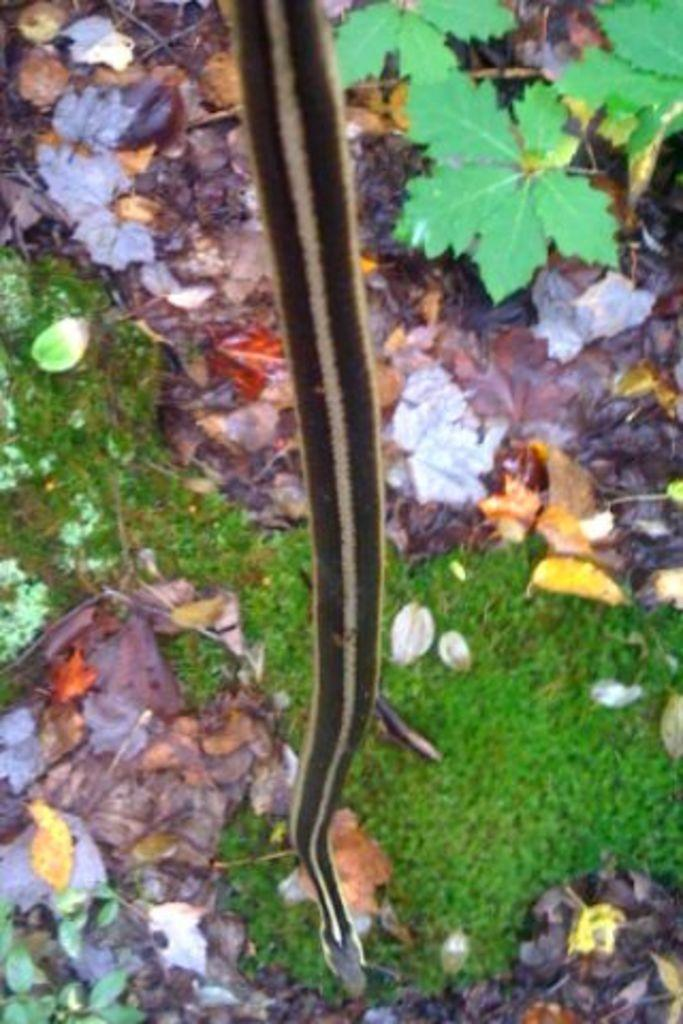What type of animal can be seen in the picture? There is a snake in the picture. What type of vegetation is present in the picture? There is grass and plants in the picture. What can be found on the floor in the picture? Dry leaves are present on the floor in the picture. How many rabbits can be seen hopping around in the picture? There are no rabbits present in the image; it features a snake and vegetation. What type of wish can be granted by the snake in the picture? There is no indication in the image that the snake can grant wishes, as it is a living creature and not a magical being. 